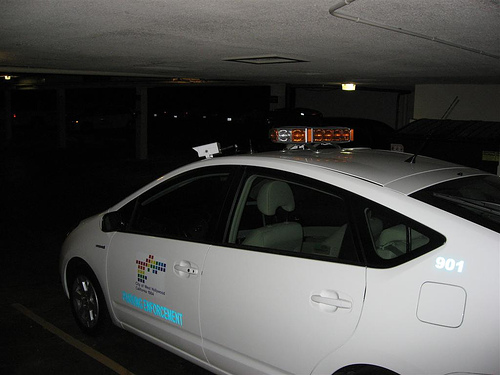<image>
Is there a car next to the opening? No. The car is not positioned next to the opening. They are located in different areas of the scene. 